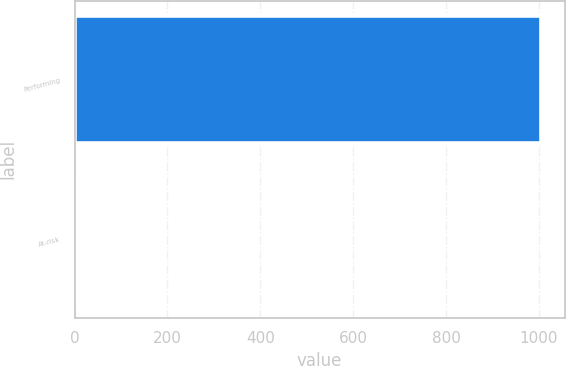<chart> <loc_0><loc_0><loc_500><loc_500><bar_chart><fcel>Performing<fcel>At-risk<nl><fcel>1005.2<fcel>6.1<nl></chart> 